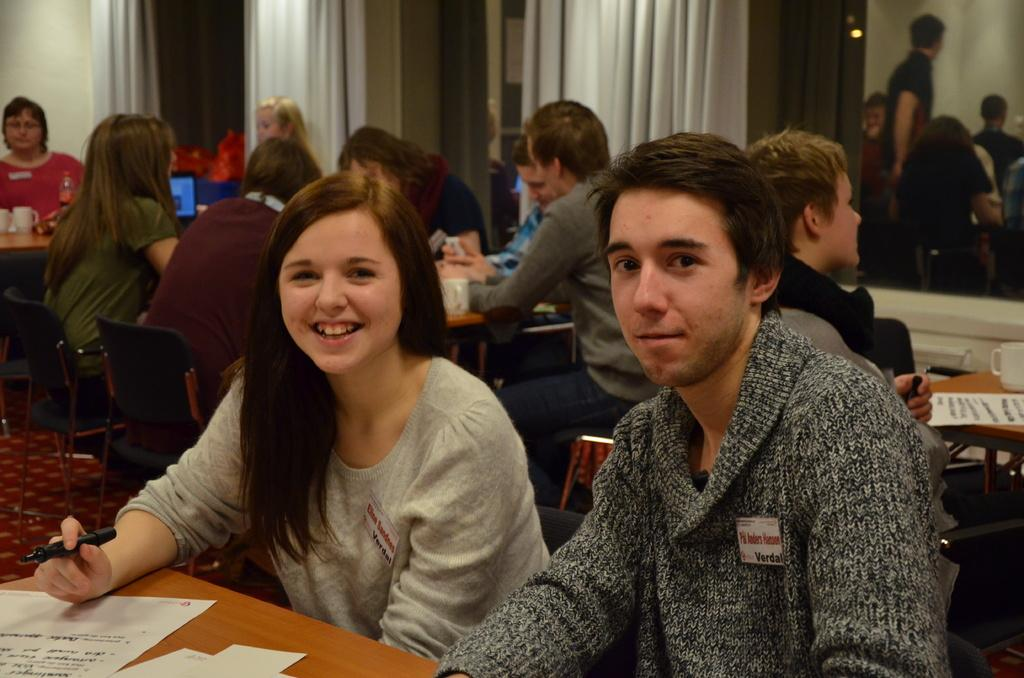What are the people in the image doing? The people in the image are sitting on chairs. What objects are in front of the people? There are tables in front of the people. What can be found on the tables? There are items present on the tables. What type of range is visible in the image? There is no range visible in the image. 